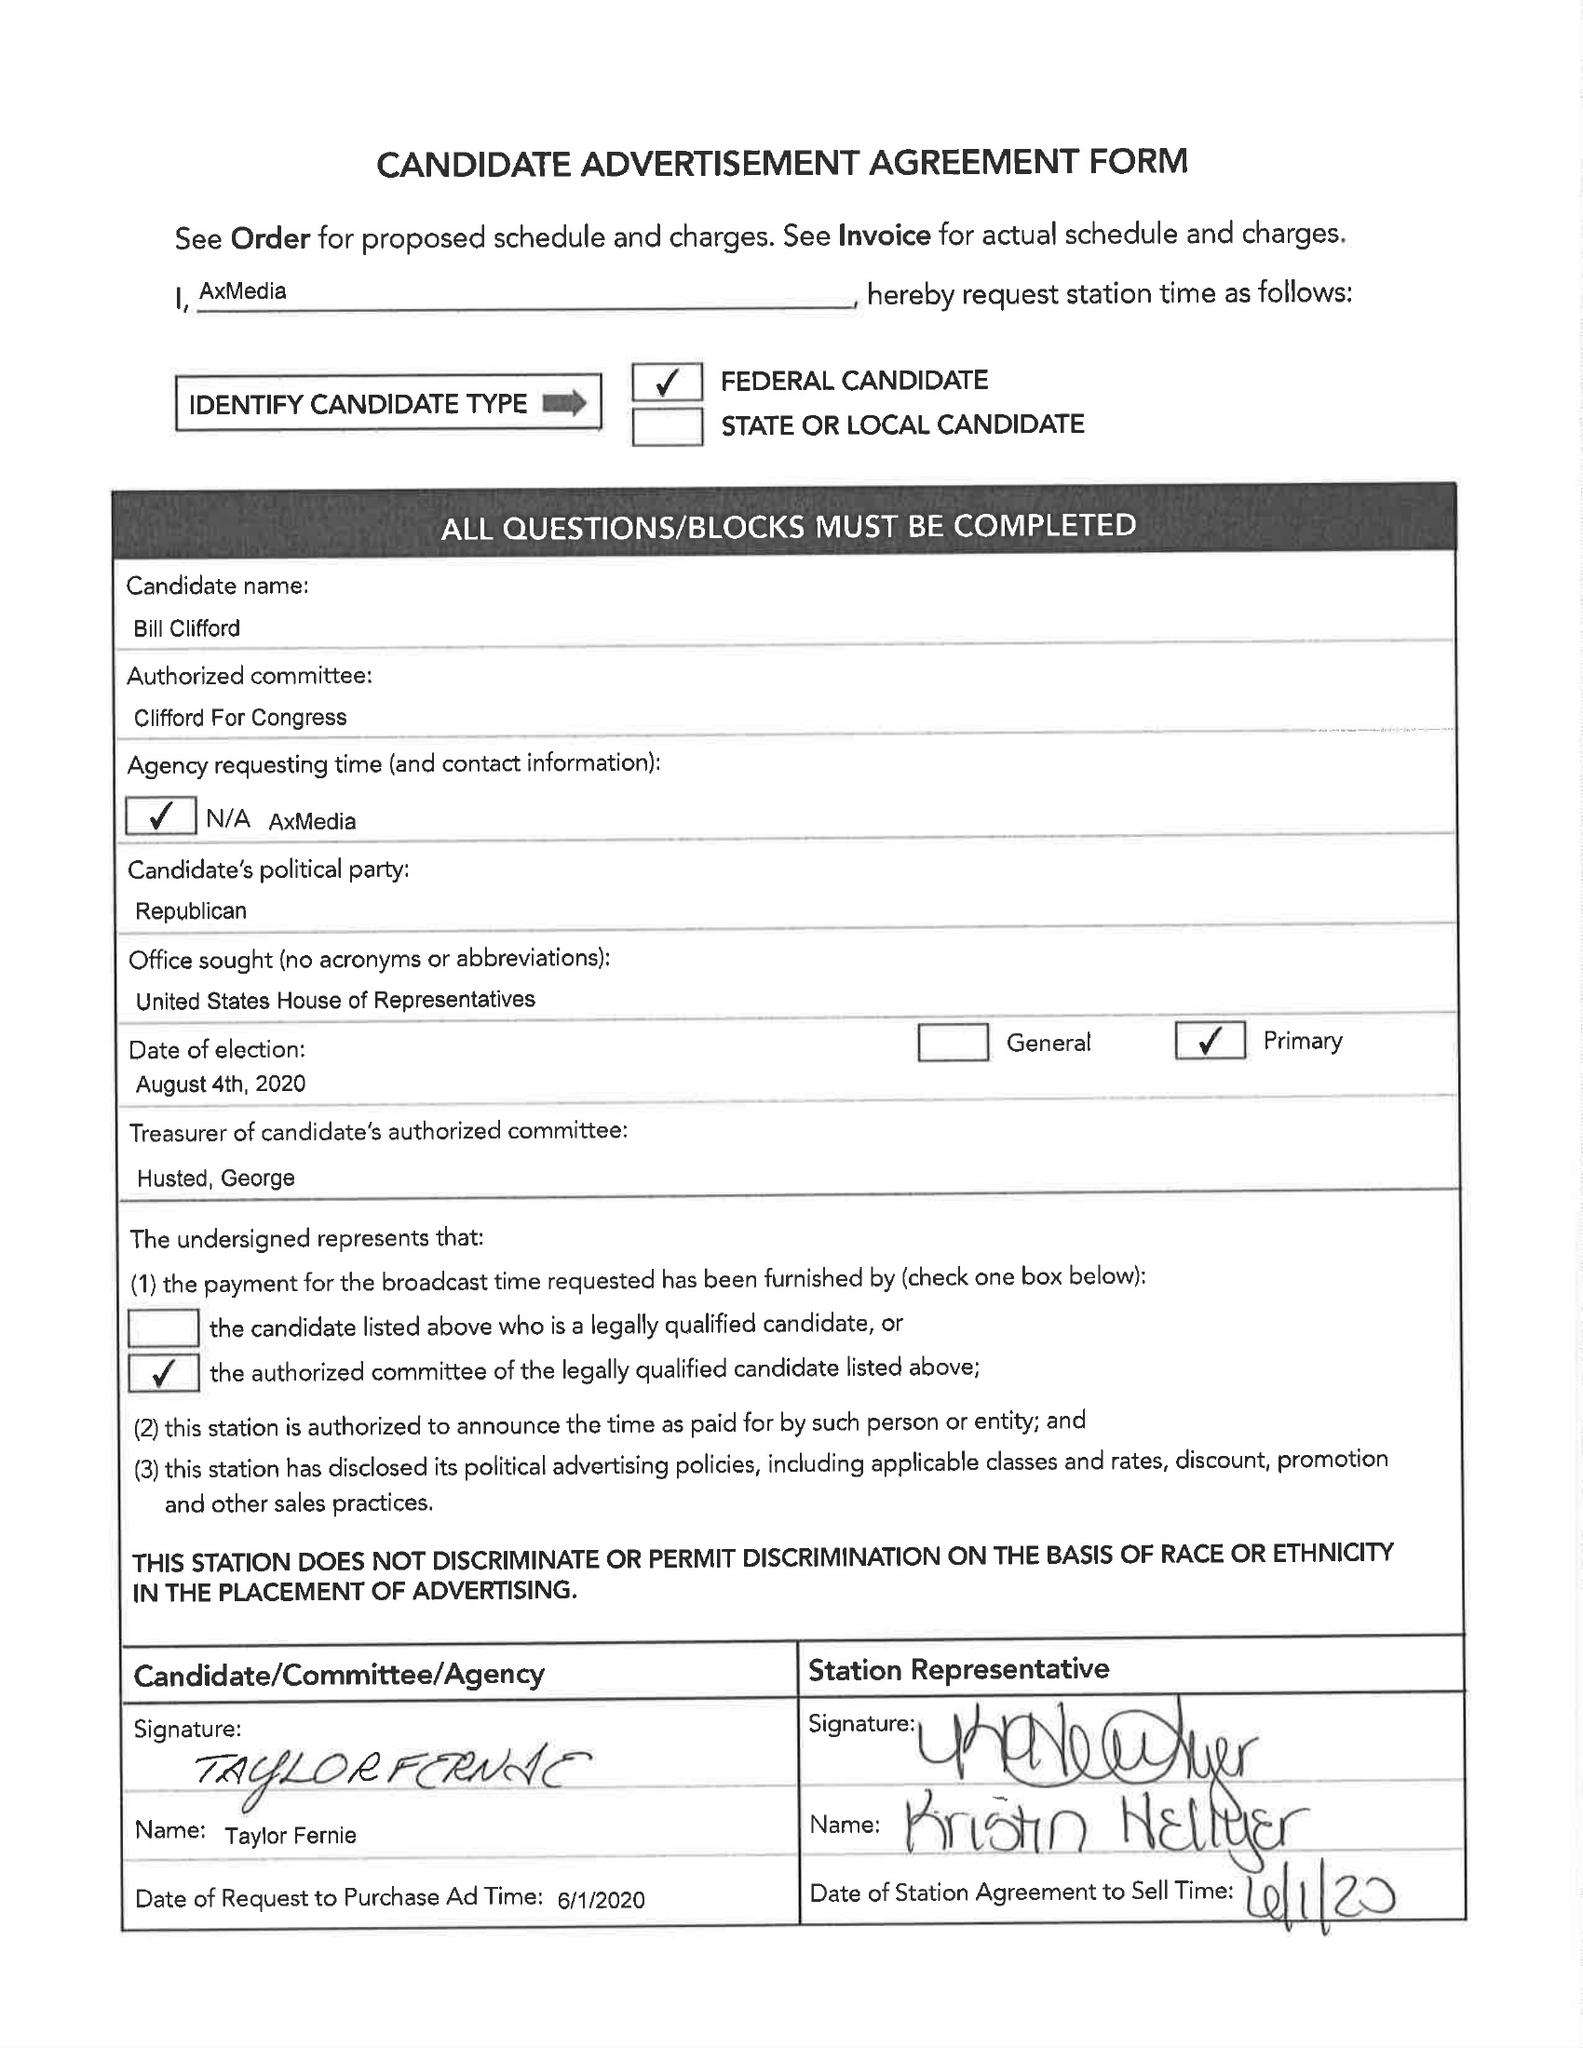What is the value for the advertiser?
Answer the question using a single word or phrase. None 